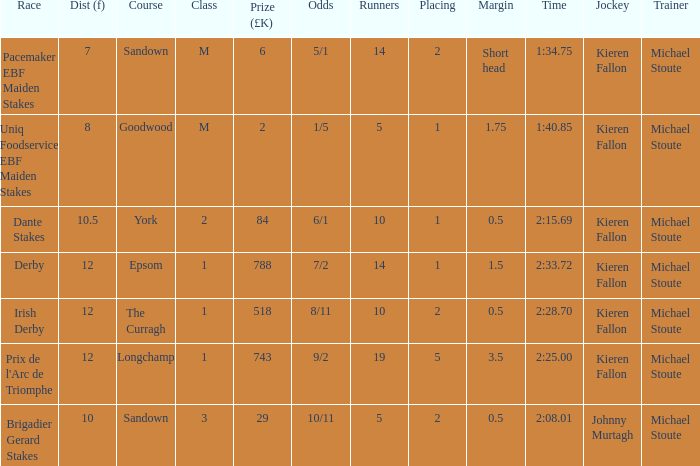What is the minimum number of runners that completed a 10.5 distance? 10.0. 